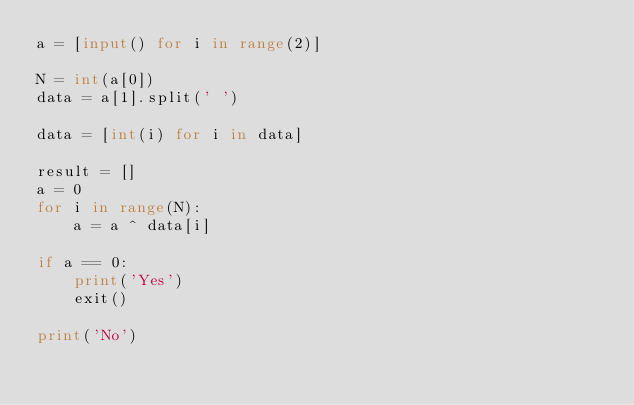Convert code to text. <code><loc_0><loc_0><loc_500><loc_500><_Python_>a = [input() for i in range(2)]
 
N = int(a[0])
data = a[1].split(' ')
 
data = [int(i) for i in data]
 
result = []
a = 0
for i in range(N):
    a = a ^ data[i]
    
if a == 0:
    print('Yes')
    exit()
    
print('No')
</code> 